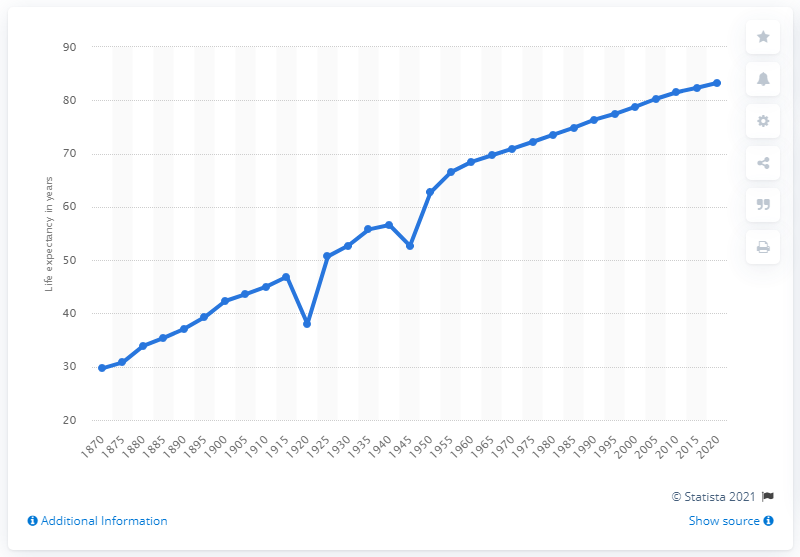Give some essential details in this illustration. In the year 1870, the life expectancy of the Italian population was just under thirty years old. 